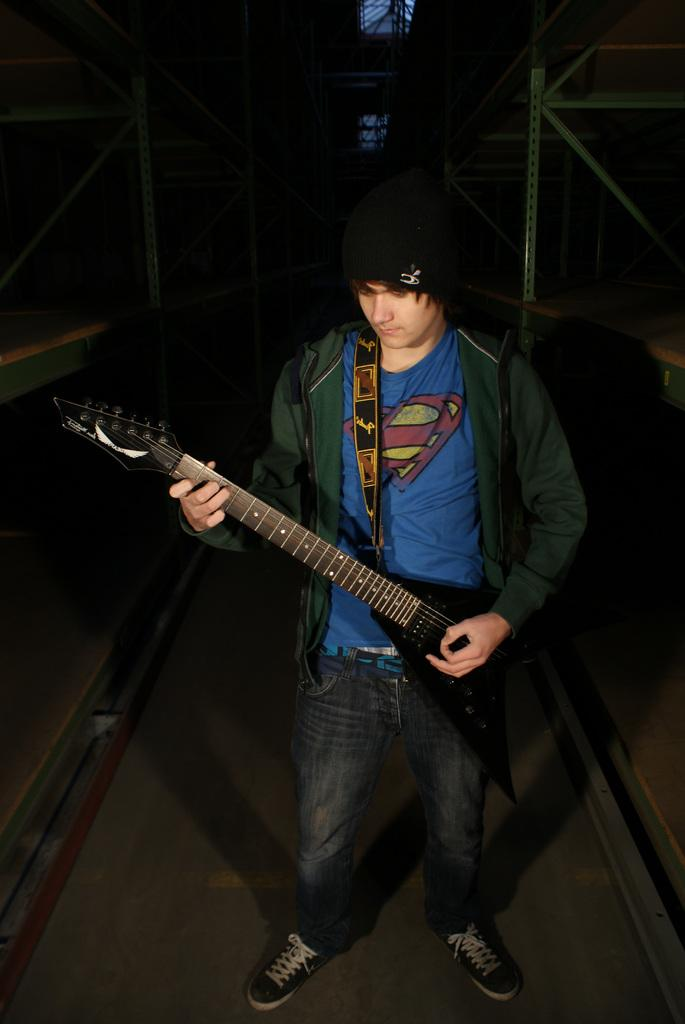What is the main subject of the image? There is a person in the image. What is the person doing in the image? The person is standing in the image. What object is the person holding in the image? The person is holding a guitar in his hand. What direction is the person facing in the image? The provided facts do not specify the direction the person is facing, so we cannot definitively answer this question. 